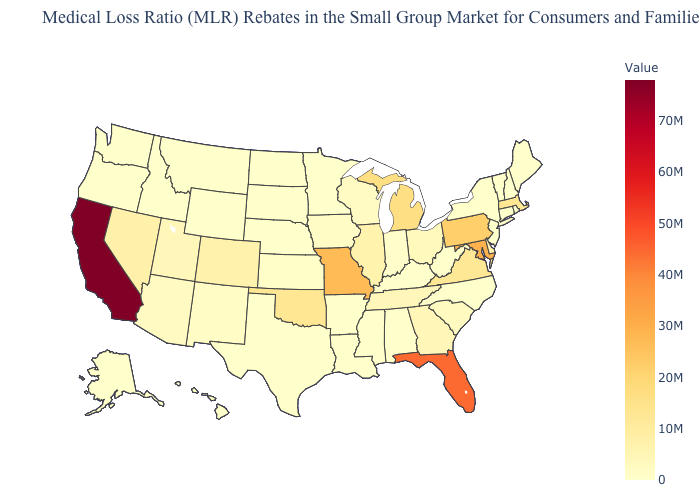Does Florida have a lower value than California?
Answer briefly. Yes. Does Delaware have the highest value in the South?
Quick response, please. No. Among the states that border New Mexico , does Texas have the highest value?
Short answer required. No. Among the states that border New York , which have the highest value?
Give a very brief answer. Pennsylvania. Does California have the lowest value in the West?
Quick response, please. No. Does California have the highest value in the USA?
Answer briefly. Yes. Does Oregon have the lowest value in the USA?
Be succinct. Yes. Which states have the lowest value in the USA?
Write a very short answer. Alabama, Alaska, Arkansas, Connecticut, Hawaii, Idaho, Kentucky, Louisiana, Maine, Minnesota, Mississippi, Montana, Nebraska, New Hampshire, New Jersey, New York, North Carolina, North Dakota, Oregon, Rhode Island, South Dakota, Texas, Vermont, Washington, West Virginia, Wyoming. 